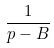Convert formula to latex. <formula><loc_0><loc_0><loc_500><loc_500>\frac { 1 } { p - B }</formula> 